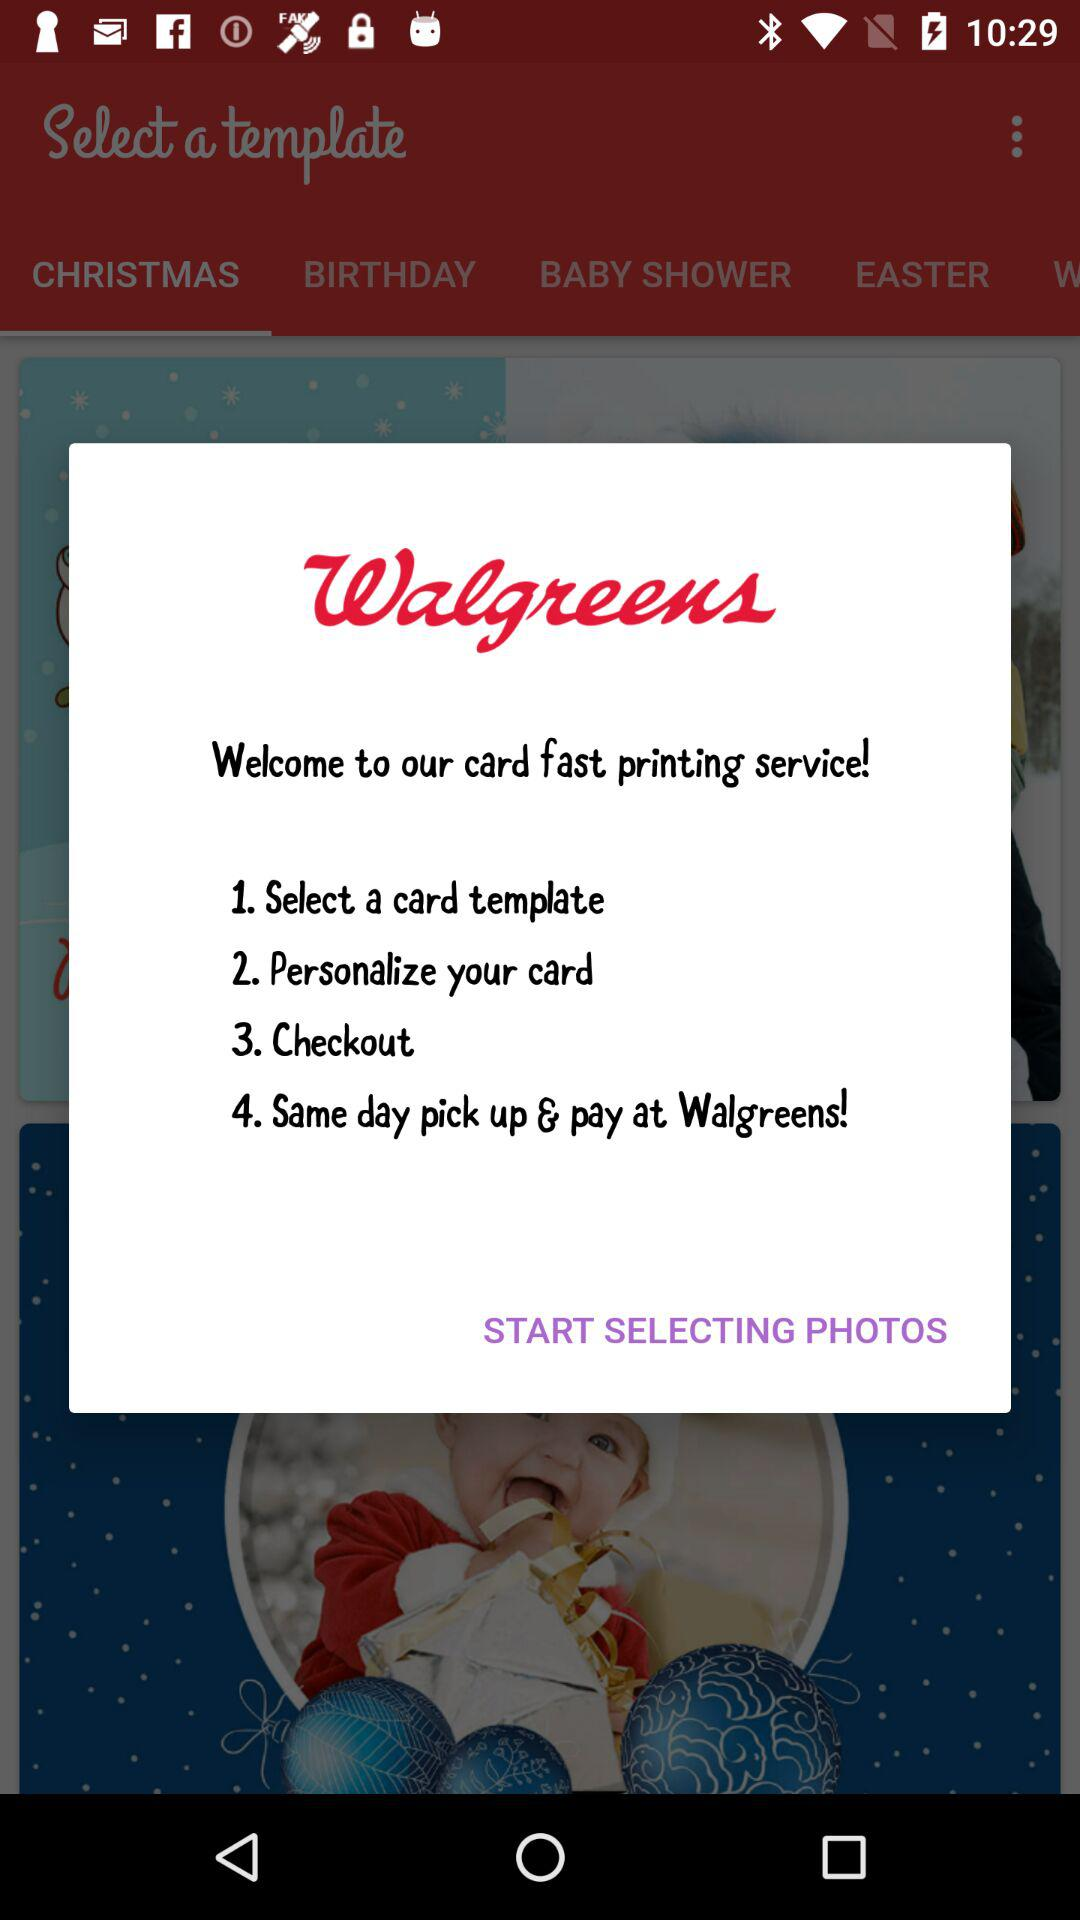How many steps are there in the process?
Answer the question using a single word or phrase. 4 